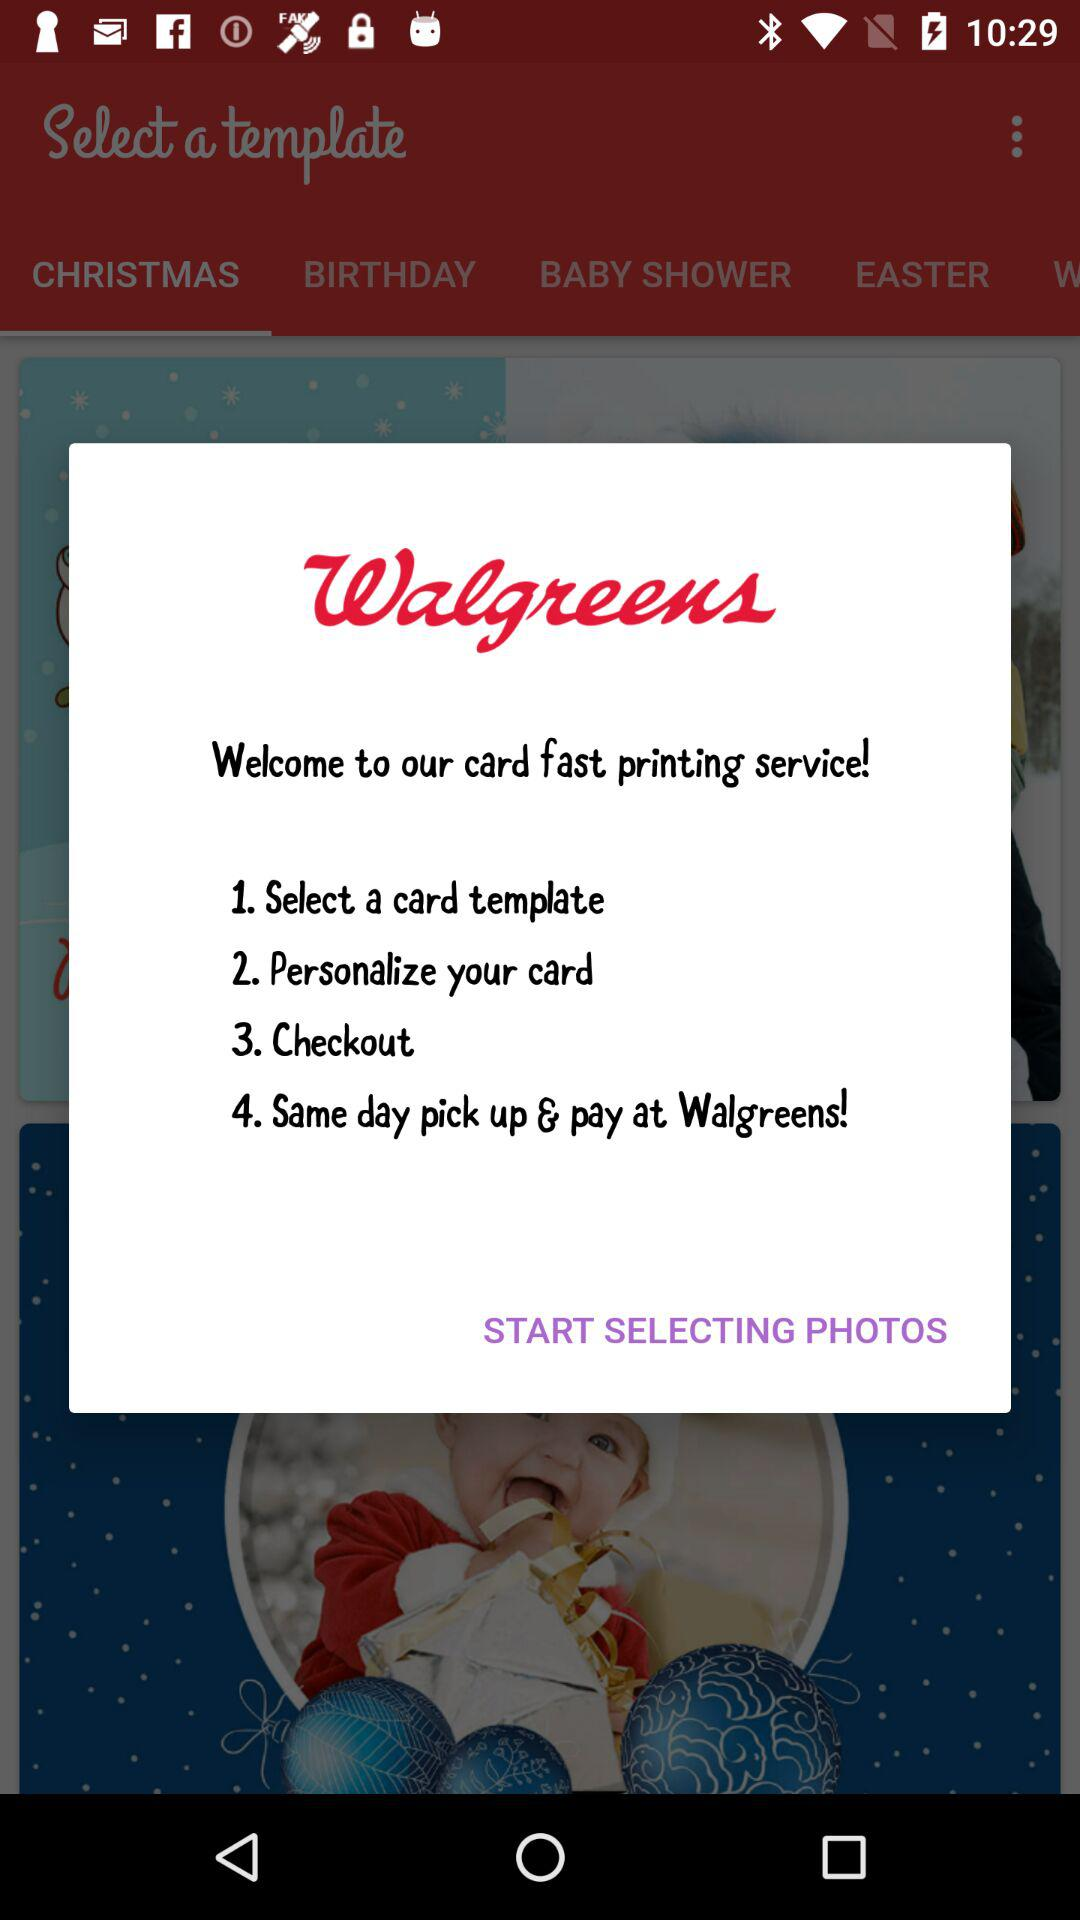How many steps are there in the process?
Answer the question using a single word or phrase. 4 